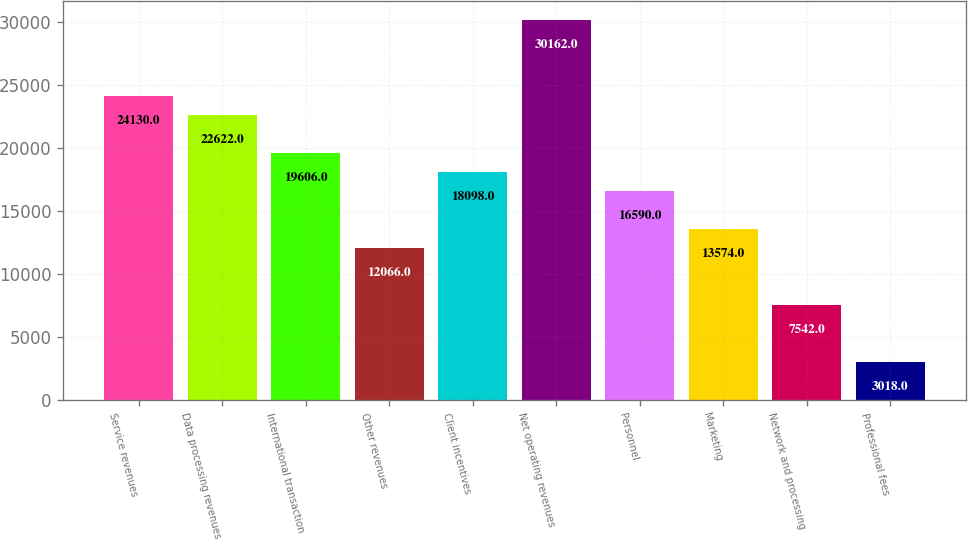<chart> <loc_0><loc_0><loc_500><loc_500><bar_chart><fcel>Service revenues<fcel>Data processing revenues<fcel>International transaction<fcel>Other revenues<fcel>Client incentives<fcel>Net operating revenues<fcel>Personnel<fcel>Marketing<fcel>Network and processing<fcel>Professional fees<nl><fcel>24130<fcel>22622<fcel>19606<fcel>12066<fcel>18098<fcel>30162<fcel>16590<fcel>13574<fcel>7542<fcel>3018<nl></chart> 